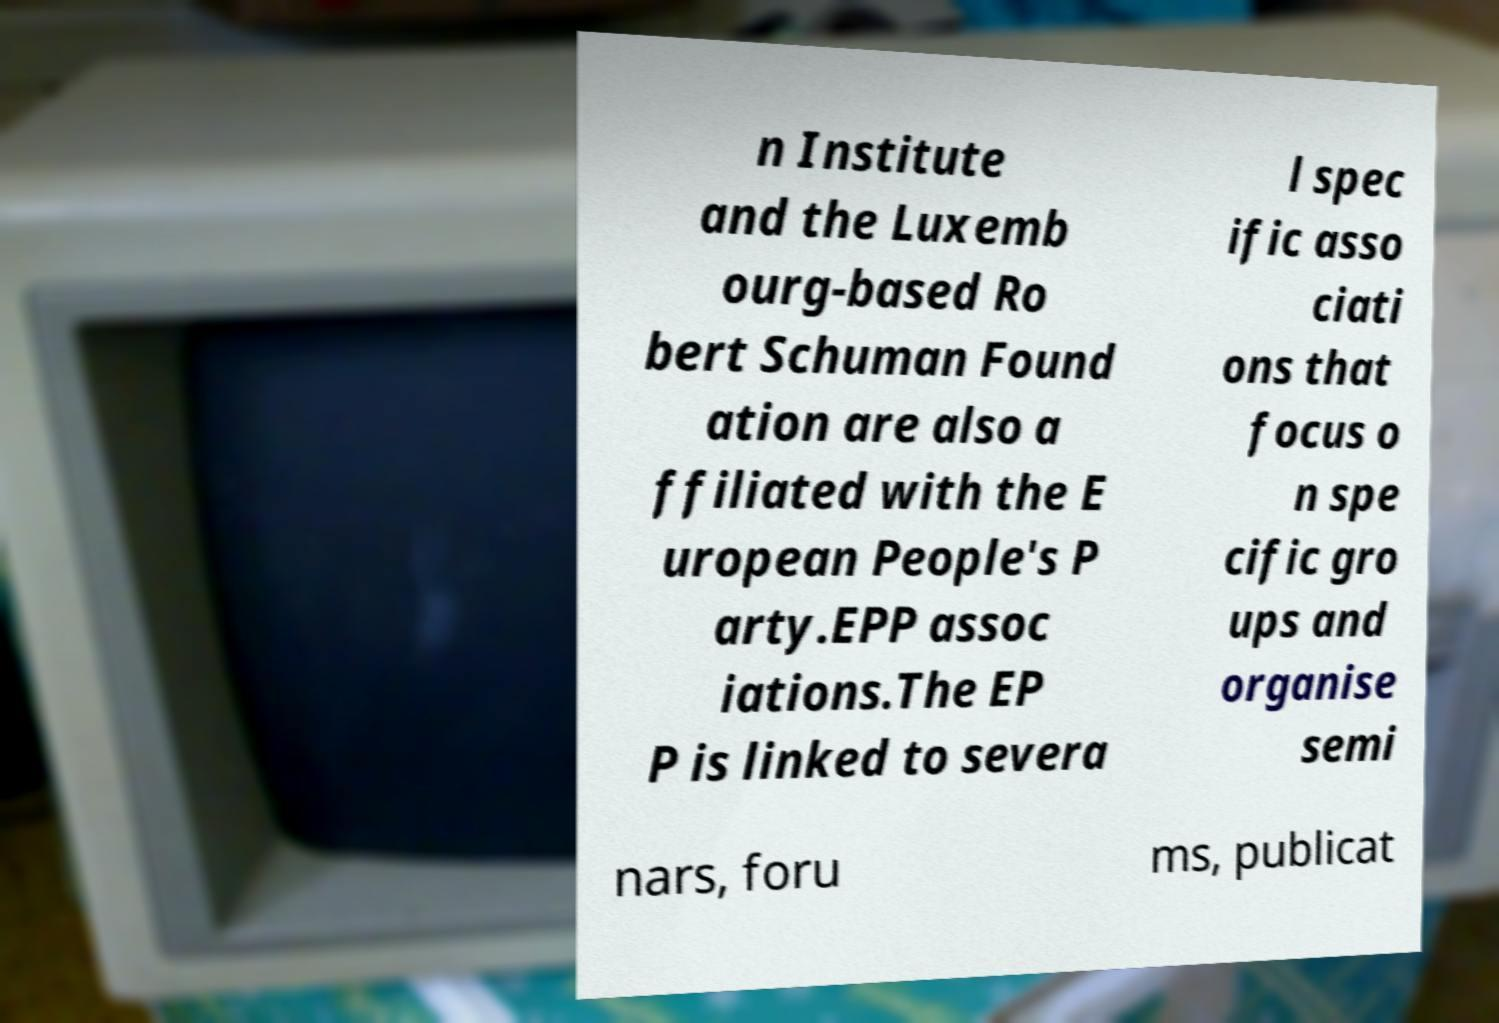Please read and relay the text visible in this image. What does it say? n Institute and the Luxemb ourg-based Ro bert Schuman Found ation are also a ffiliated with the E uropean People's P arty.EPP assoc iations.The EP P is linked to severa l spec ific asso ciati ons that focus o n spe cific gro ups and organise semi nars, foru ms, publicat 